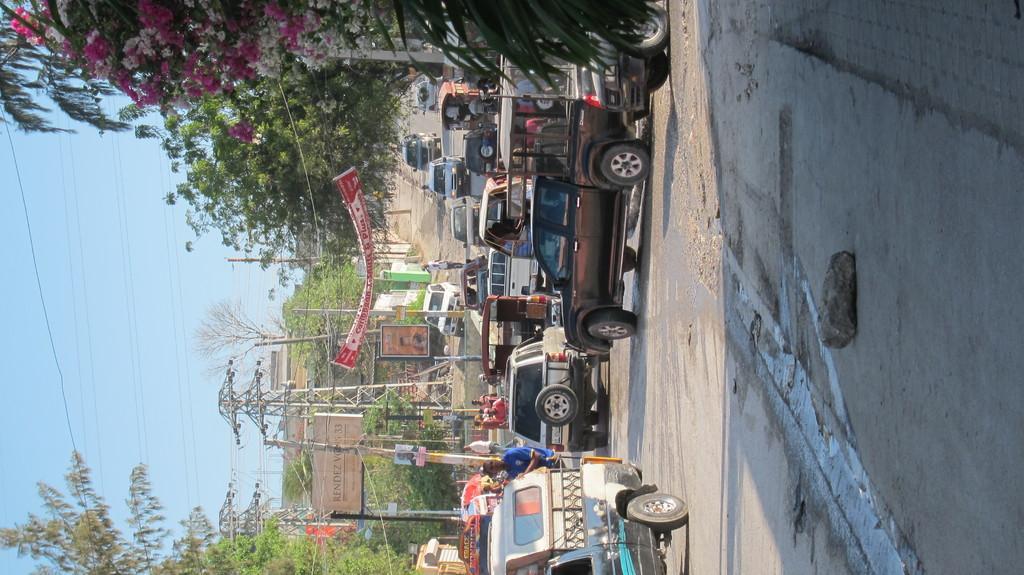In one or two sentences, can you explain what this image depicts? In this picture we can see vehicles and people on the ground and in the background we can see buildings, trees, poles, banner, posters and the sky. 